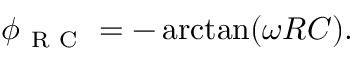<formula> <loc_0><loc_0><loc_500><loc_500>\phi _ { R C } = - \arctan ( \omega R C ) .</formula> 